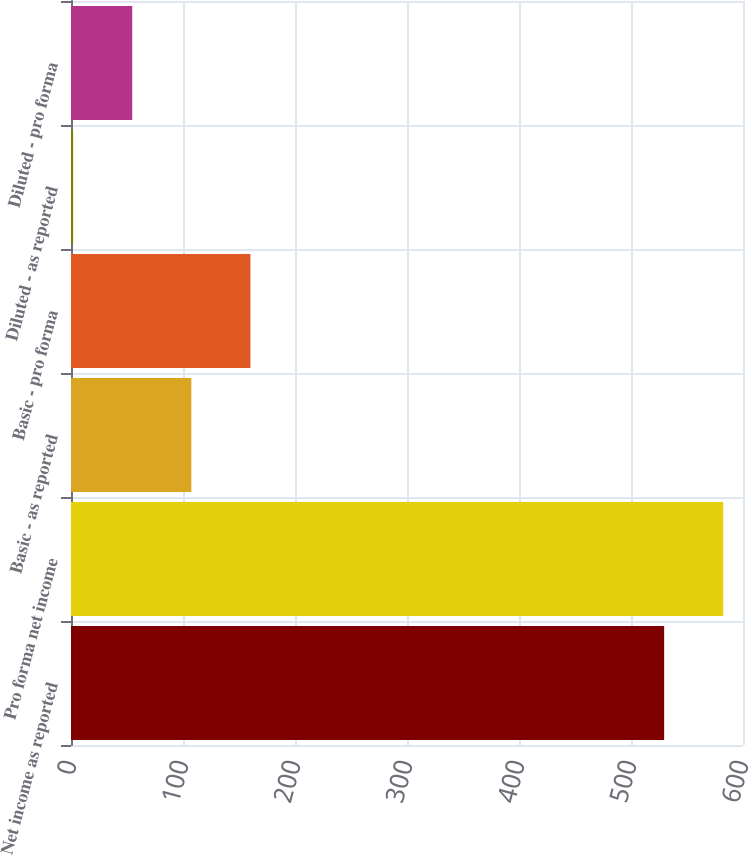<chart> <loc_0><loc_0><loc_500><loc_500><bar_chart><fcel>Net income as reported<fcel>Pro forma net income<fcel>Basic - as reported<fcel>Basic - pro forma<fcel>Diluted - as reported<fcel>Diluted - pro forma<nl><fcel>529.6<fcel>582.37<fcel>107.44<fcel>160.21<fcel>1.9<fcel>54.67<nl></chart> 